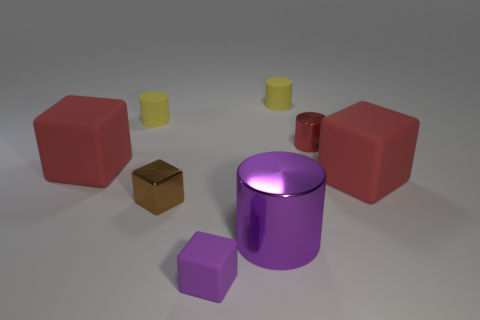What number of metallic things are either tiny brown objects or large purple cylinders?
Offer a very short reply. 2. There is a red matte object that is on the left side of the red matte object to the right of the small brown thing; what size is it?
Ensure brevity in your answer.  Large. There is a large cylinder that is the same color as the tiny rubber cube; what is its material?
Keep it short and to the point. Metal. There is a large red object on the right side of the purple object to the right of the small purple rubber object; are there any big red blocks that are on the left side of it?
Give a very brief answer. Yes. Is the material of the big block to the right of the purple cylinder the same as the tiny block behind the purple cylinder?
Your answer should be compact. No. How many objects are either large metallic blocks or objects that are in front of the big cylinder?
Give a very brief answer. 1. What number of cyan matte things are the same shape as the small brown shiny thing?
Ensure brevity in your answer.  0. What material is the red thing that is the same size as the brown thing?
Give a very brief answer. Metal. What size is the rubber cube that is right of the large metallic object that is left of the large rubber cube that is on the right side of the big cylinder?
Give a very brief answer. Large. There is a big rubber thing that is right of the brown block; is it the same color as the small matte cylinder on the right side of the big purple cylinder?
Offer a terse response. No. 